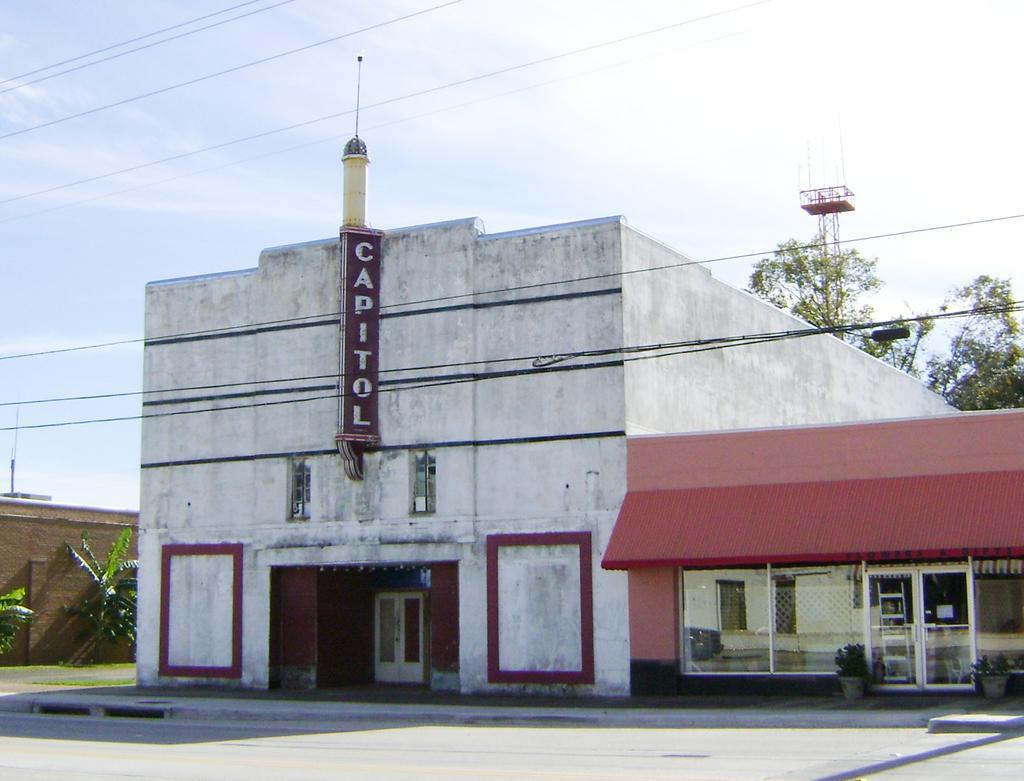Please provide a concise description of this image. In the foreground of this image, there are two buildings, doors, glass windows, cables , trees and the sky. 